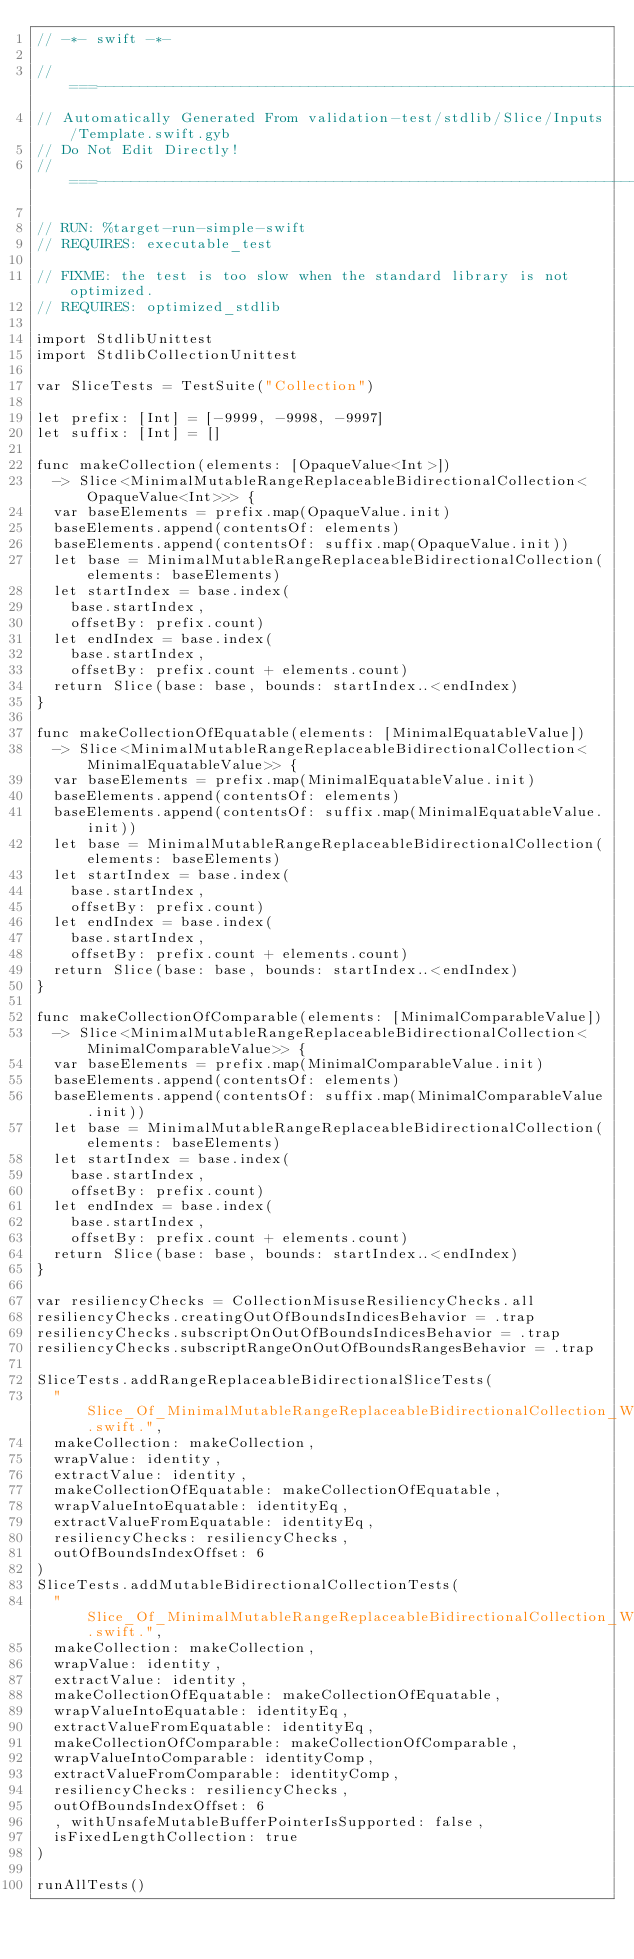Convert code to text. <code><loc_0><loc_0><loc_500><loc_500><_Swift_>// -*- swift -*-

//===----------------------------------------------------------------------===//
// Automatically Generated From validation-test/stdlib/Slice/Inputs/Template.swift.gyb
// Do Not Edit Directly!
//===----------------------------------------------------------------------===//

// RUN: %target-run-simple-swift
// REQUIRES: executable_test

// FIXME: the test is too slow when the standard library is not optimized.
// REQUIRES: optimized_stdlib

import StdlibUnittest
import StdlibCollectionUnittest

var SliceTests = TestSuite("Collection")

let prefix: [Int] = [-9999, -9998, -9997]
let suffix: [Int] = []

func makeCollection(elements: [OpaqueValue<Int>])
  -> Slice<MinimalMutableRangeReplaceableBidirectionalCollection<OpaqueValue<Int>>> {
  var baseElements = prefix.map(OpaqueValue.init)
  baseElements.append(contentsOf: elements)
  baseElements.append(contentsOf: suffix.map(OpaqueValue.init))
  let base = MinimalMutableRangeReplaceableBidirectionalCollection(elements: baseElements)
  let startIndex = base.index(
    base.startIndex,
    offsetBy: prefix.count)
  let endIndex = base.index(
    base.startIndex,
    offsetBy: prefix.count + elements.count)
  return Slice(base: base, bounds: startIndex..<endIndex)
}

func makeCollectionOfEquatable(elements: [MinimalEquatableValue])
  -> Slice<MinimalMutableRangeReplaceableBidirectionalCollection<MinimalEquatableValue>> {
  var baseElements = prefix.map(MinimalEquatableValue.init)
  baseElements.append(contentsOf: elements)
  baseElements.append(contentsOf: suffix.map(MinimalEquatableValue.init))
  let base = MinimalMutableRangeReplaceableBidirectionalCollection(elements: baseElements)
  let startIndex = base.index(
    base.startIndex,
    offsetBy: prefix.count)
  let endIndex = base.index(
    base.startIndex,
    offsetBy: prefix.count + elements.count)
  return Slice(base: base, bounds: startIndex..<endIndex)
}

func makeCollectionOfComparable(elements: [MinimalComparableValue])
  -> Slice<MinimalMutableRangeReplaceableBidirectionalCollection<MinimalComparableValue>> {
  var baseElements = prefix.map(MinimalComparableValue.init)
  baseElements.append(contentsOf: elements)
  baseElements.append(contentsOf: suffix.map(MinimalComparableValue.init))
  let base = MinimalMutableRangeReplaceableBidirectionalCollection(elements: baseElements)
  let startIndex = base.index(
    base.startIndex,
    offsetBy: prefix.count)
  let endIndex = base.index(
    base.startIndex,
    offsetBy: prefix.count + elements.count)
  return Slice(base: base, bounds: startIndex..<endIndex)
}

var resiliencyChecks = CollectionMisuseResiliencyChecks.all
resiliencyChecks.creatingOutOfBoundsIndicesBehavior = .trap
resiliencyChecks.subscriptOnOutOfBoundsIndicesBehavior = .trap
resiliencyChecks.subscriptRangeOnOutOfBoundsRangesBehavior = .trap

SliceTests.addRangeReplaceableBidirectionalSliceTests(
  "Slice_Of_MinimalMutableRangeReplaceableBidirectionalCollection_WithPrefix.swift.",
  makeCollection: makeCollection,
  wrapValue: identity,
  extractValue: identity,
  makeCollectionOfEquatable: makeCollectionOfEquatable,
  wrapValueIntoEquatable: identityEq,
  extractValueFromEquatable: identityEq,
  resiliencyChecks: resiliencyChecks,
  outOfBoundsIndexOffset: 6
)
SliceTests.addMutableBidirectionalCollectionTests(
  "Slice_Of_MinimalMutableRangeReplaceableBidirectionalCollection_WithPrefix.swift.",
  makeCollection: makeCollection,
  wrapValue: identity,
  extractValue: identity,
  makeCollectionOfEquatable: makeCollectionOfEquatable,
  wrapValueIntoEquatable: identityEq,
  extractValueFromEquatable: identityEq,
  makeCollectionOfComparable: makeCollectionOfComparable,
  wrapValueIntoComparable: identityComp,
  extractValueFromComparable: identityComp,
  resiliencyChecks: resiliencyChecks,
  outOfBoundsIndexOffset: 6
  , withUnsafeMutableBufferPointerIsSupported: false,
  isFixedLengthCollection: true
)

runAllTests()
</code> 